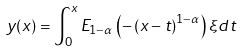Convert formula to latex. <formula><loc_0><loc_0><loc_500><loc_500>y ( x ) = \int _ { 0 } ^ { x } E _ { 1 - \alpha } \left ( - \left ( x - t \right ) ^ { 1 - \alpha } \right ) \xi d t</formula> 